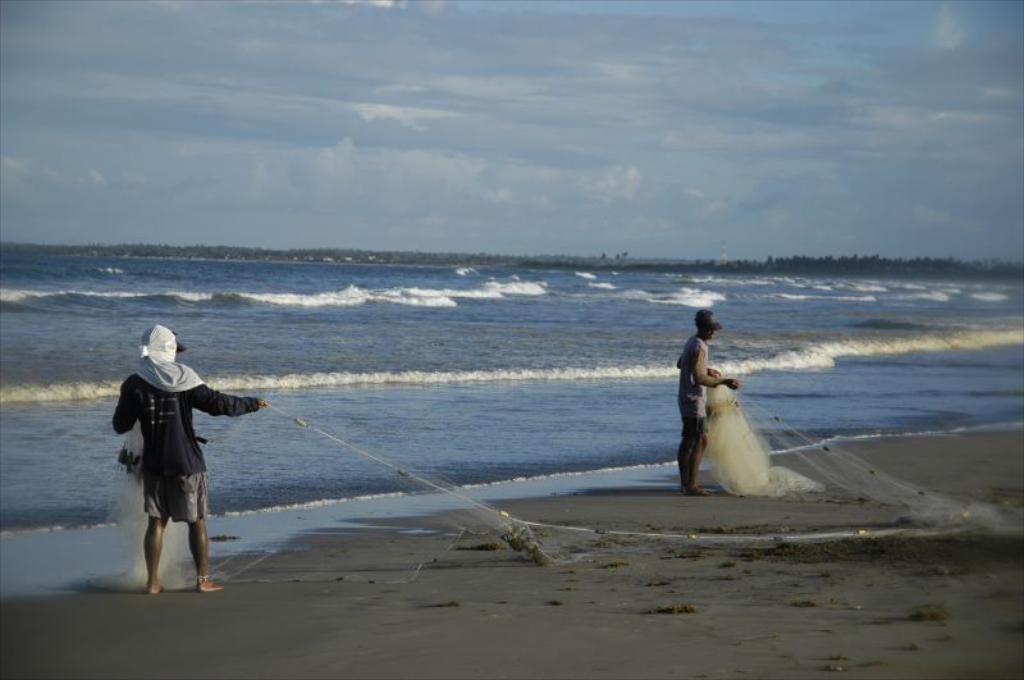How many people are in the image? There are two men in the image. Where are the men located in the image? The men are standing on the beach. What are the men holding in their hands? The men are holding fish nets in their hands. What can be seen in the background of the image? The background of the image includes the sea. What is the condition of the sky in the image? The sky is covered with clouds. What type of trucks can be seen in the image? There are no trucks present in the image. What shape is the memory taking in the image? There is no memory depicted in the image; it is a photograph of two men on the beach. 